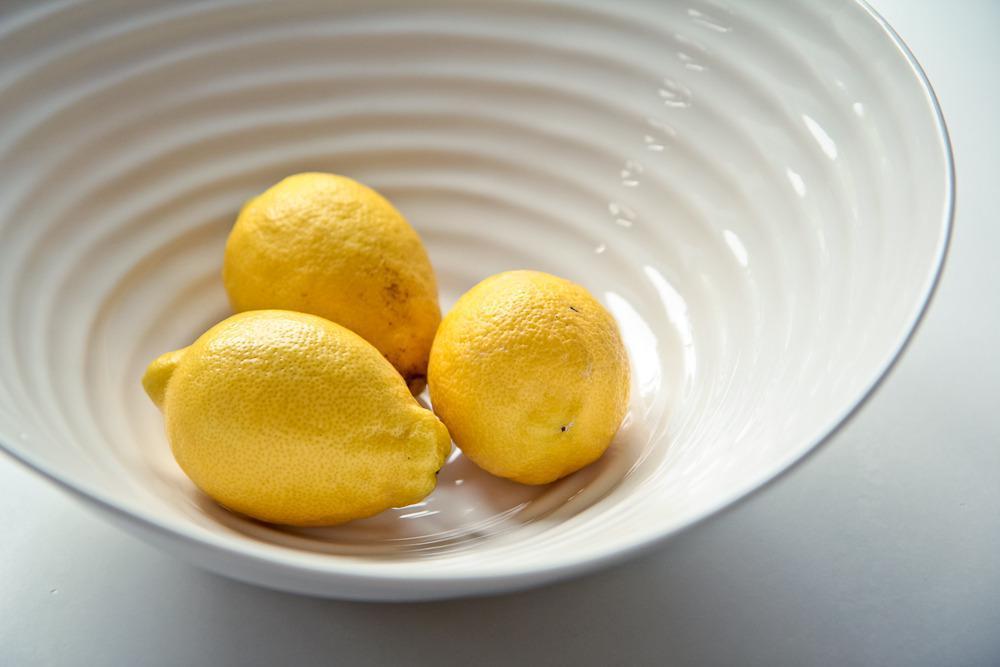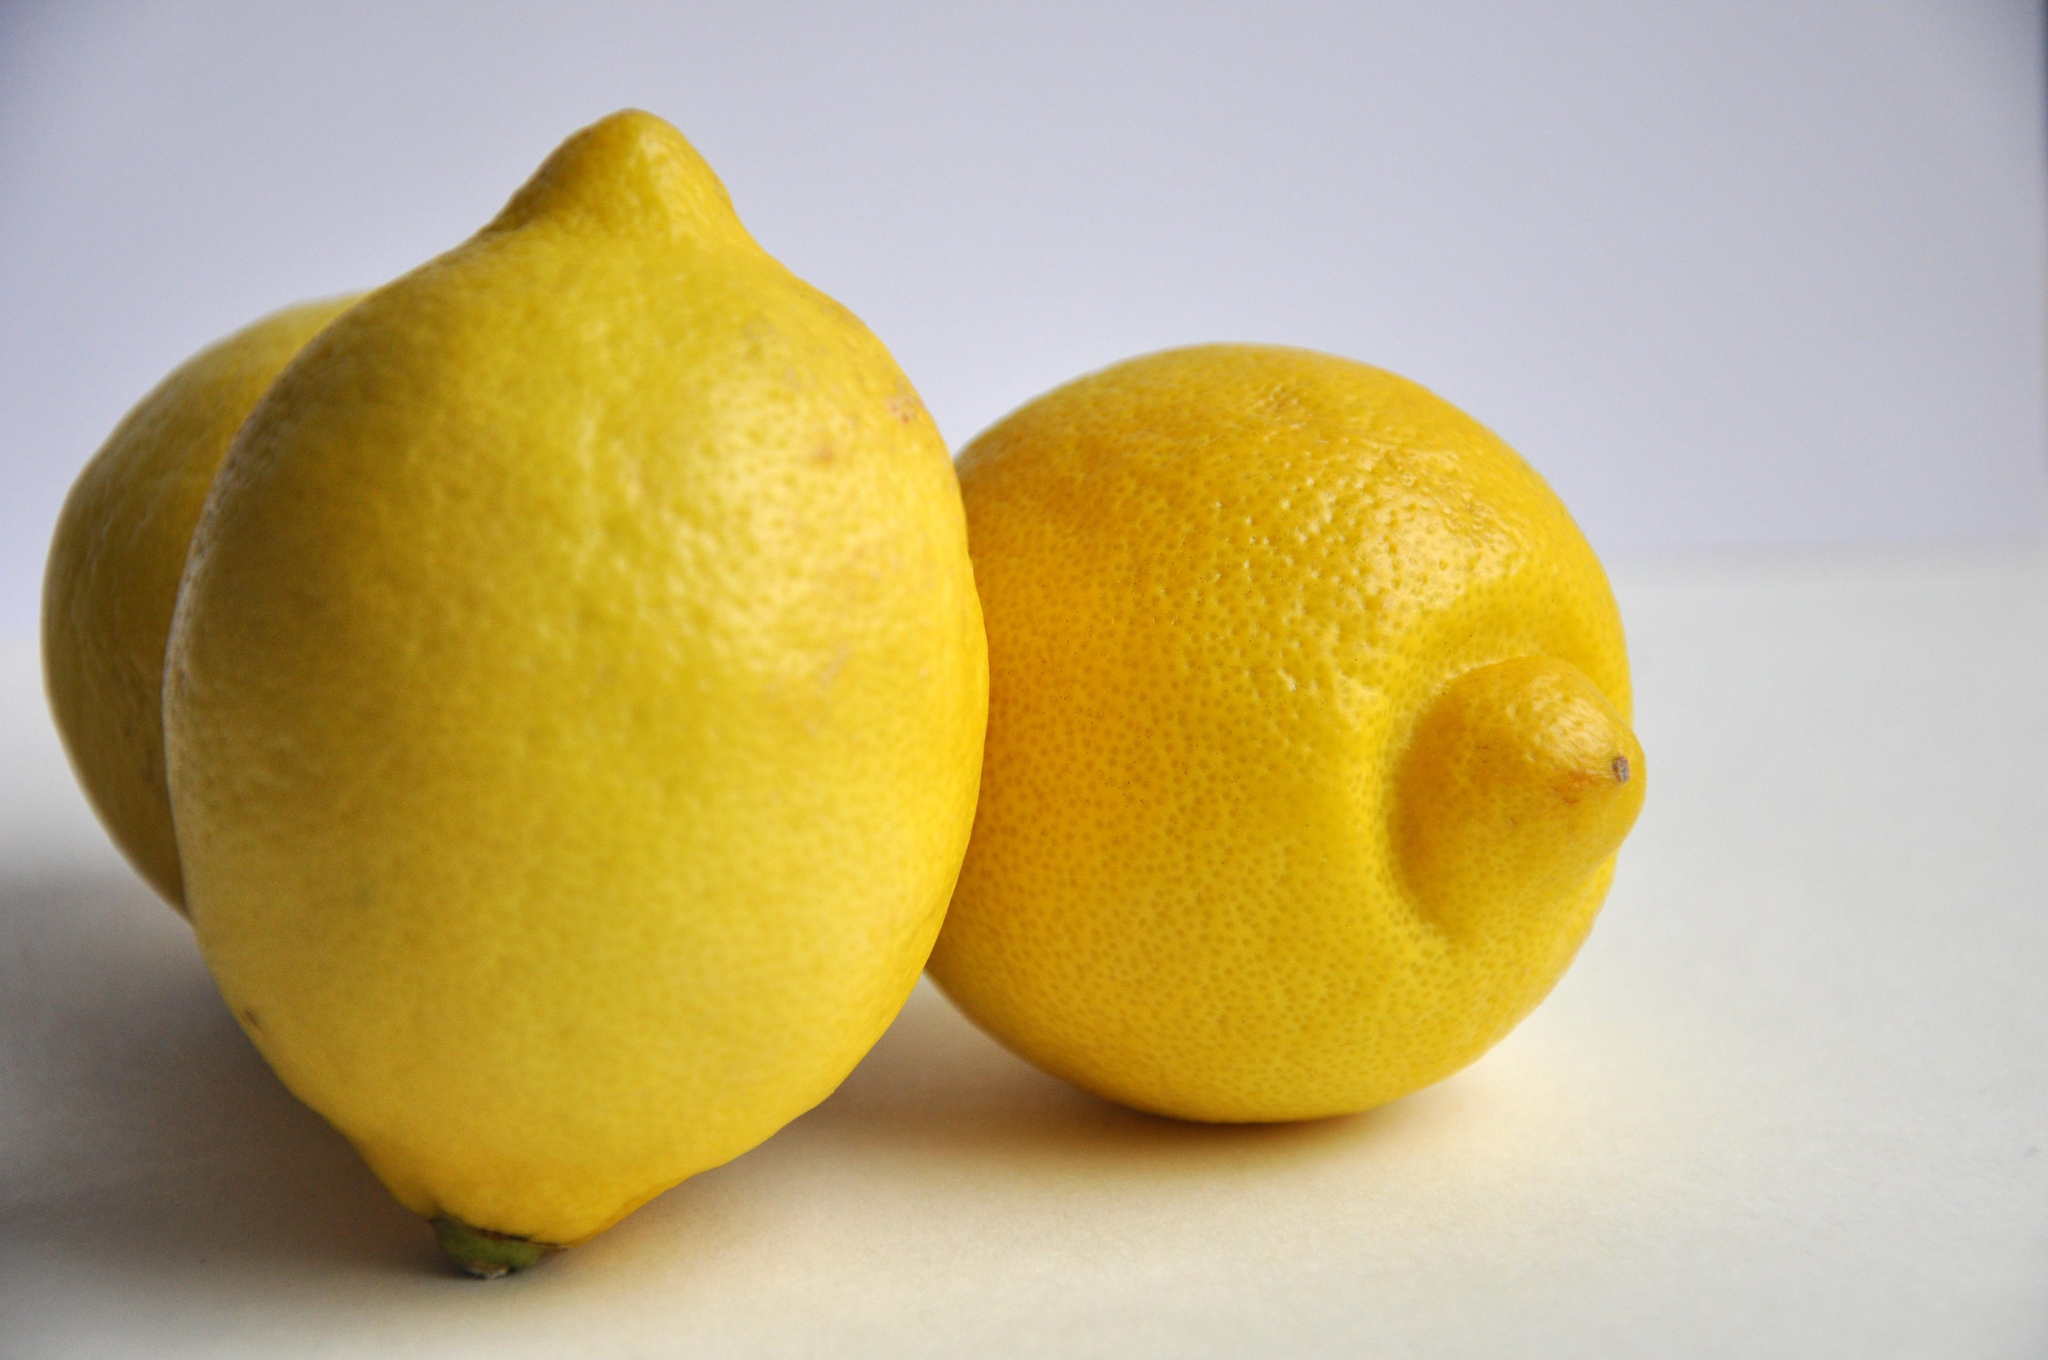The first image is the image on the left, the second image is the image on the right. Evaluate the accuracy of this statement regarding the images: "In one image there is a combination of sliced and whole lemons, and in the other image there are three whole lemons". Is it true? Answer yes or no. No. The first image is the image on the left, the second image is the image on the right. For the images shown, is this caption "In one image, some lemons are cut, in the other, none of the lemons are cut." true? Answer yes or no. No. 